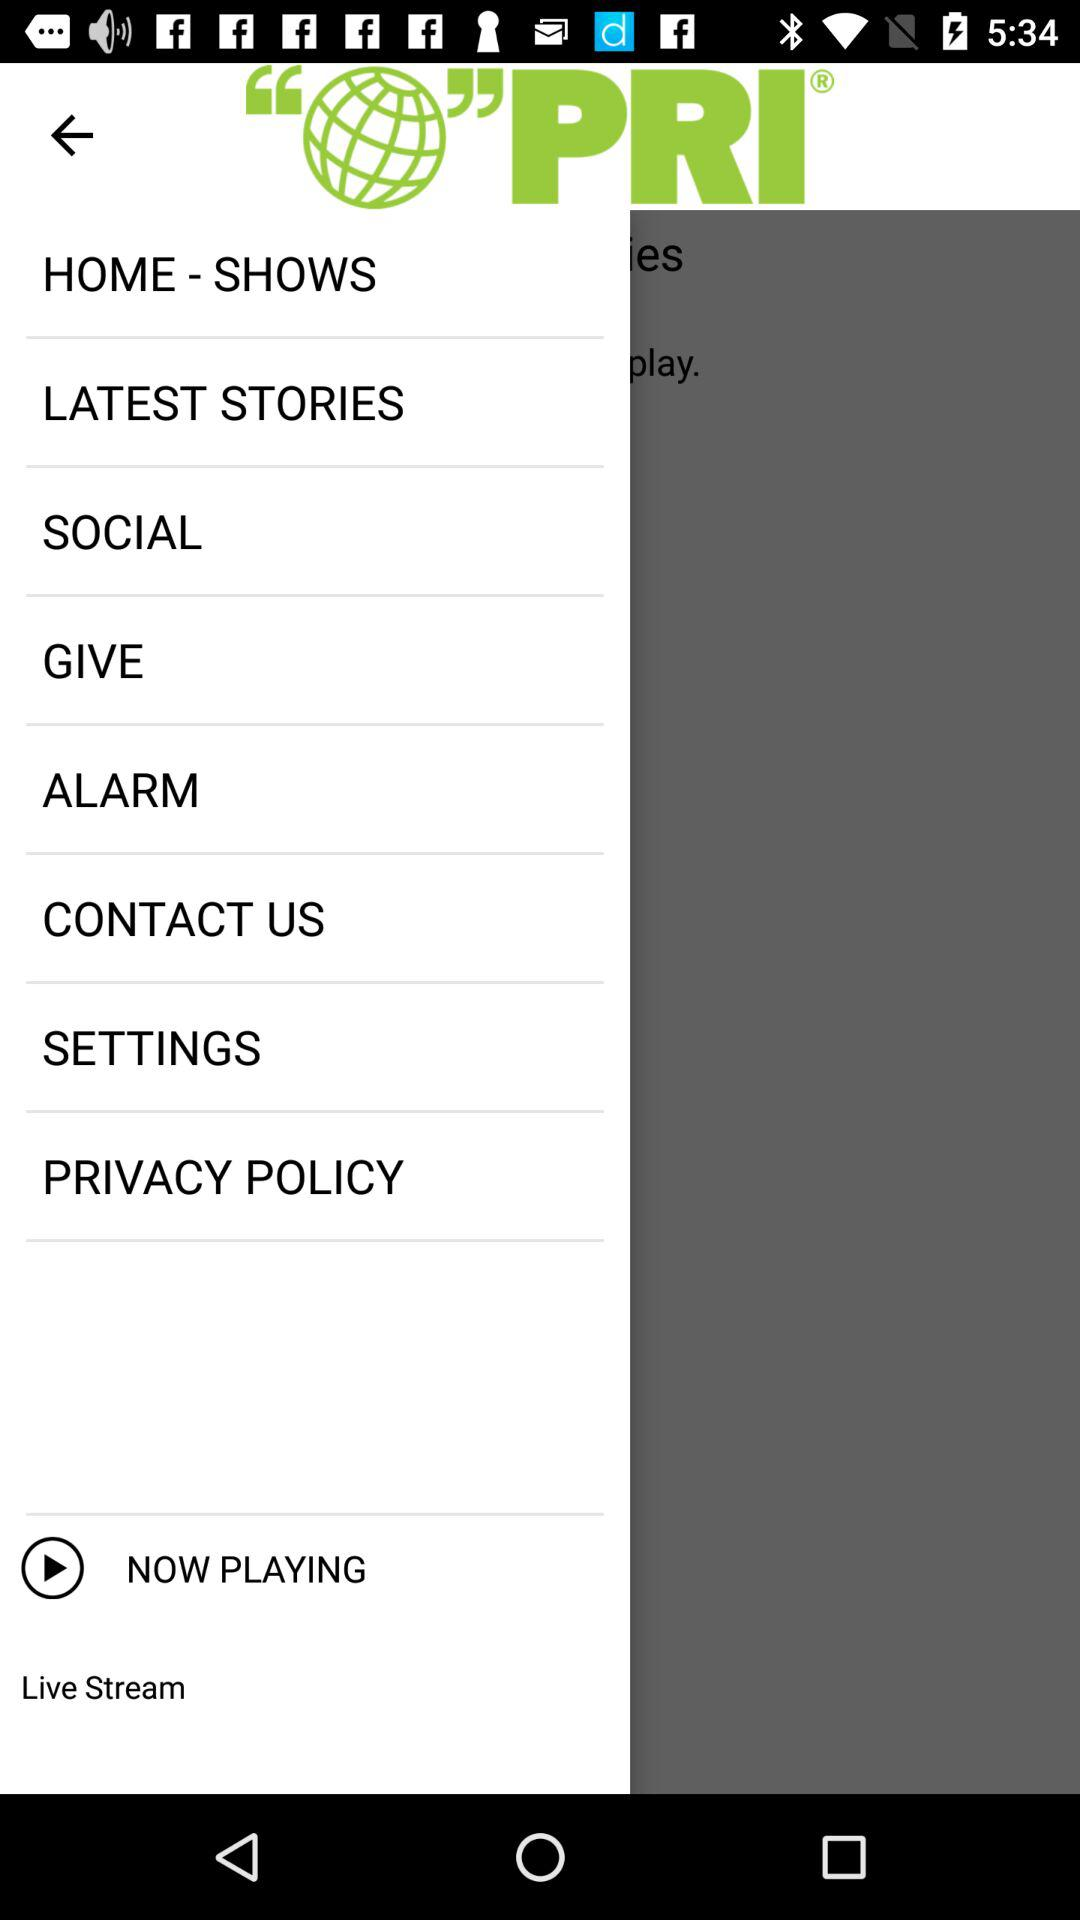What is the name of the application? The name of the application is "PRI". 